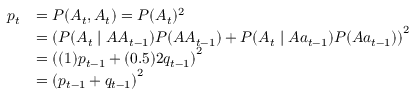Convert formula to latex. <formula><loc_0><loc_0><loc_500><loc_500>{ \begin{array} { r l } { p _ { t } } & { = P ( A _ { t } , A _ { t } ) = P ( A _ { t } ) ^ { 2 } } \\ & { = \left ( P ( A _ { t } | A A _ { t - 1 } ) P ( A A _ { t - 1 } ) + P ( A _ { t } | A a _ { t - 1 } ) P ( A a _ { t - 1 } ) \right ) ^ { 2 } } \\ & { = \left ( ( 1 ) p _ { t - 1 } + ( 0 . 5 ) 2 q _ { t - 1 } \right ) ^ { 2 } } \\ & { = \left ( p _ { t - 1 } + q _ { t - 1 } \right ) ^ { 2 } } \end{array} }</formula> 